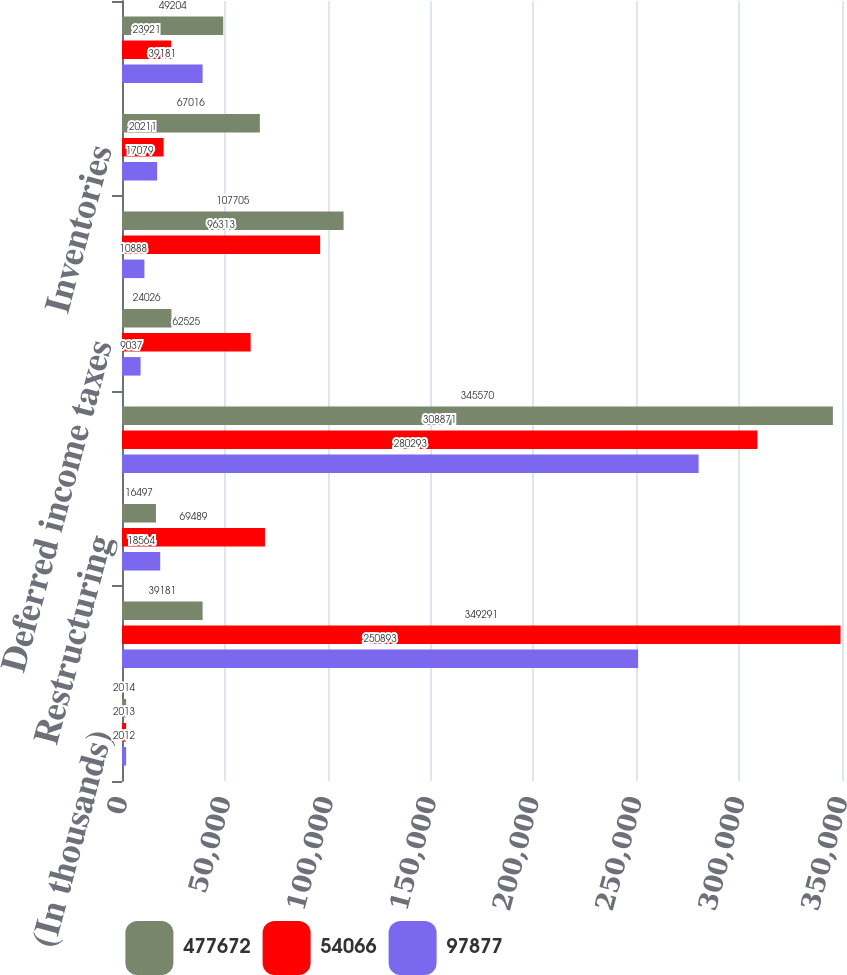<chart> <loc_0><loc_0><loc_500><loc_500><stacked_bar_chart><ecel><fcel>(In thousands)<fcel>Net earnings<fcel>Restructuring<fcel>Depreciation and amortization<fcel>Deferred income taxes<fcel>Receivables net<fcel>Inventories<fcel>Accounts payable and accrued<nl><fcel>477672<fcel>2014<fcel>39181<fcel>16497<fcel>345570<fcel>24026<fcel>107705<fcel>67016<fcel>49204<nl><fcel>54066<fcel>2013<fcel>349291<fcel>69489<fcel>308871<fcel>62525<fcel>96313<fcel>20211<fcel>23921<nl><fcel>97877<fcel>2012<fcel>250893<fcel>18564<fcel>280293<fcel>9037<fcel>10888<fcel>17079<fcel>39181<nl></chart> 